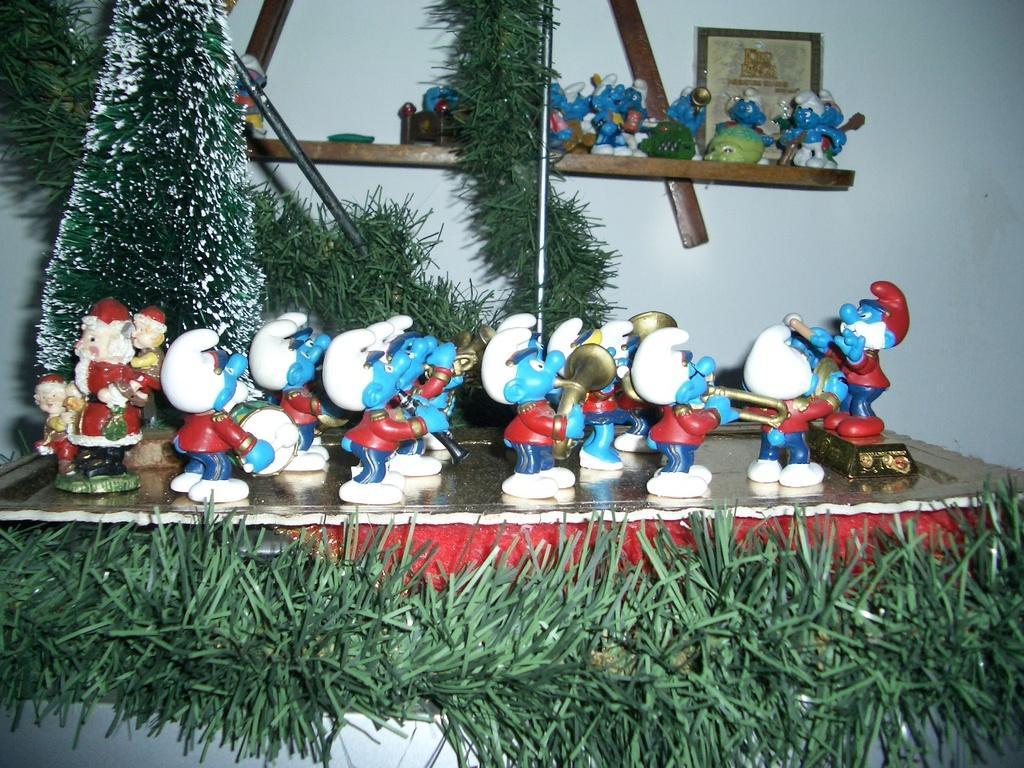Please provide a concise description of this image. Here we can see toys and grass. In the background there is a frame and a wall. 